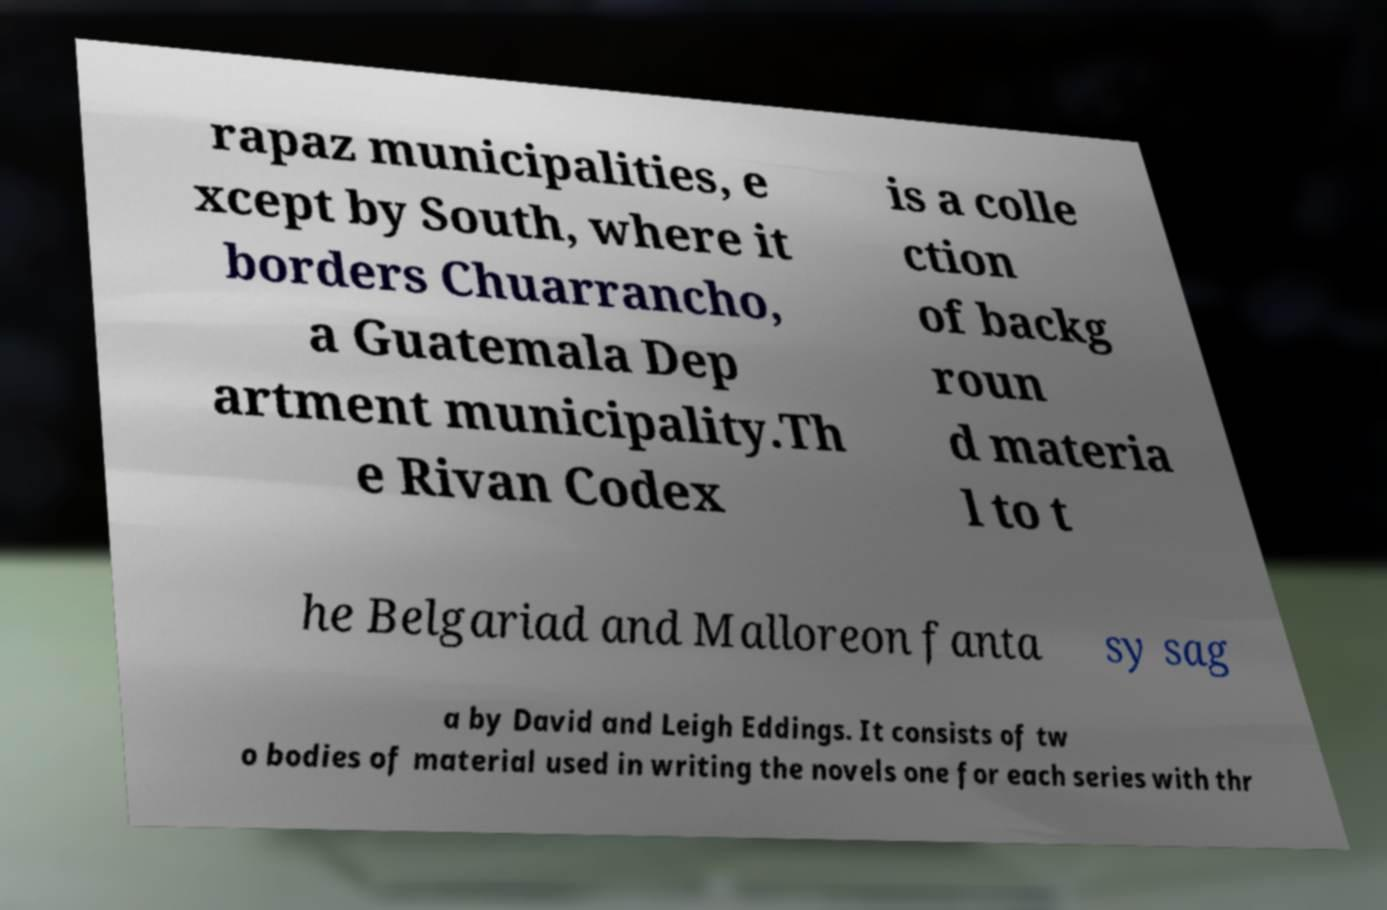Can you read and provide the text displayed in the image?This photo seems to have some interesting text. Can you extract and type it out for me? rapaz municipalities, e xcept by South, where it borders Chuarrancho, a Guatemala Dep artment municipality.Th e Rivan Codex is a colle ction of backg roun d materia l to t he Belgariad and Malloreon fanta sy sag a by David and Leigh Eddings. It consists of tw o bodies of material used in writing the novels one for each series with thr 